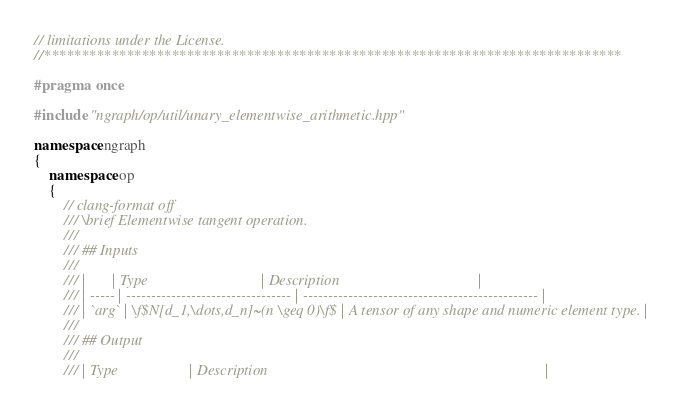<code> <loc_0><loc_0><loc_500><loc_500><_C++_>// limitations under the License.
//*****************************************************************************

#pragma once

#include "ngraph/op/util/unary_elementwise_arithmetic.hpp"

namespace ngraph
{
    namespace op
    {
        // clang-format off
        /// \brief Elementwise tangent operation.
        ///
        /// ## Inputs
        ///
        /// |       | Type                              | Description                                     |
        /// | ----- | --------------------------------- | ----------------------------------------------- |
        /// | `arg` | \f$N[d_1,\dots,d_n]~(n \geq 0)\f$ | A tensor of any shape and numeric element type. |
        ///
        /// ## Output
        ///
        /// | Type                   | Description                                                                          |</code> 